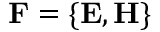<formula> <loc_0><loc_0><loc_500><loc_500>F = \{ E , H \}</formula> 